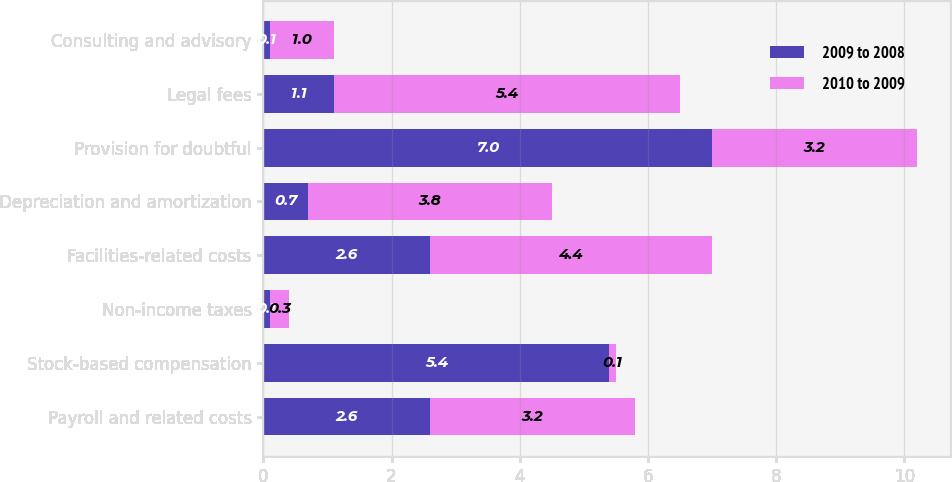Convert chart. <chart><loc_0><loc_0><loc_500><loc_500><stacked_bar_chart><ecel><fcel>Payroll and related costs<fcel>Stock-based compensation<fcel>Non-income taxes<fcel>Facilities-related costs<fcel>Depreciation and amortization<fcel>Provision for doubtful<fcel>Legal fees<fcel>Consulting and advisory<nl><fcel>2009 to 2008<fcel>2.6<fcel>5.4<fcel>0.1<fcel>2.6<fcel>0.7<fcel>7<fcel>1.1<fcel>0.1<nl><fcel>2010 to 2009<fcel>3.2<fcel>0.1<fcel>0.3<fcel>4.4<fcel>3.8<fcel>3.2<fcel>5.4<fcel>1<nl></chart> 